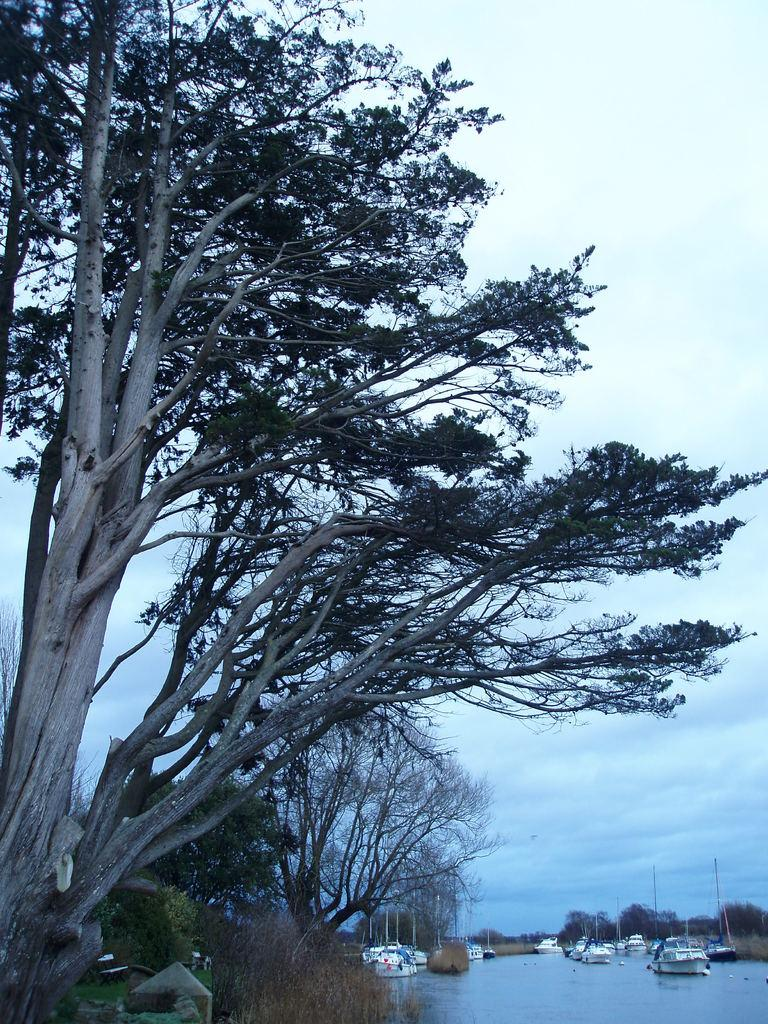What type of vegetation is on the left side of the image? There are trees and grass on the left side of the image. What can be seen in the center of the image? There are boats, trees, and poles in the center of the image. What is the main feature of the center of the image? There is a water body in the center of the image. What type of pear is being discussed by the committee in the image? There is no pear or committee present in the image. How can one obtain credit for the boats in the image? There is no mention of credit or any need to obtain credit for the boats in the image. 